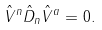<formula> <loc_0><loc_0><loc_500><loc_500>\hat { V } ^ { n } \hat { D } _ { n } \hat { V } ^ { a } = 0 .</formula> 